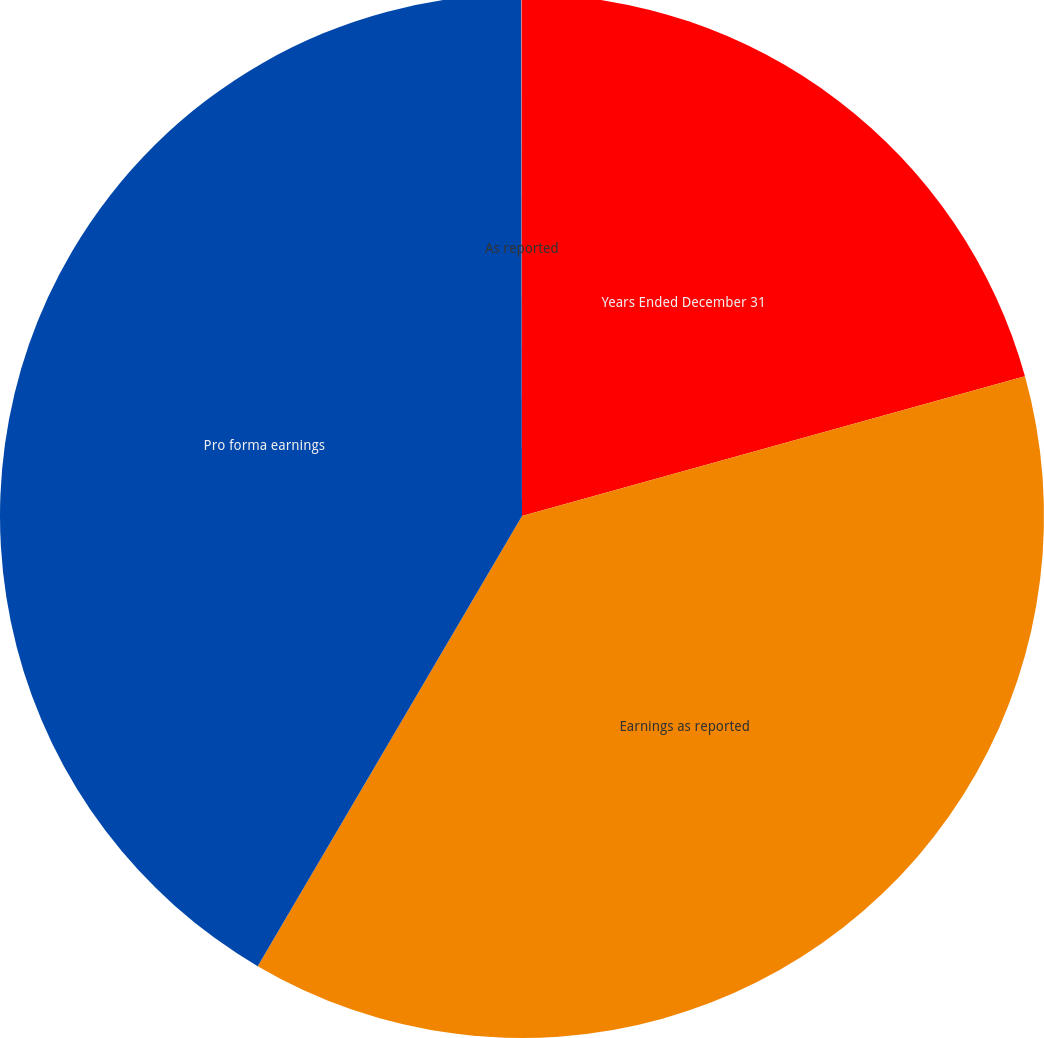Convert chart. <chart><loc_0><loc_0><loc_500><loc_500><pie_chart><fcel>Years Ended December 31<fcel>Earnings as reported<fcel>Pro forma earnings<fcel>As reported<nl><fcel>20.69%<fcel>37.76%<fcel>41.53%<fcel>0.02%<nl></chart> 